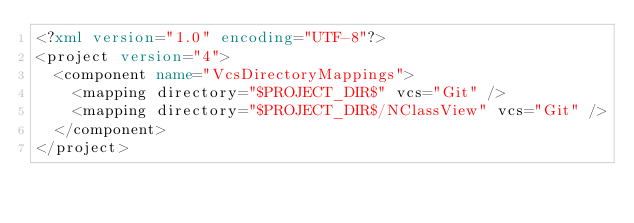Convert code to text. <code><loc_0><loc_0><loc_500><loc_500><_XML_><?xml version="1.0" encoding="UTF-8"?>
<project version="4">
  <component name="VcsDirectoryMappings">
    <mapping directory="$PROJECT_DIR$" vcs="Git" />
    <mapping directory="$PROJECT_DIR$/NClassView" vcs="Git" />
  </component>
</project></code> 